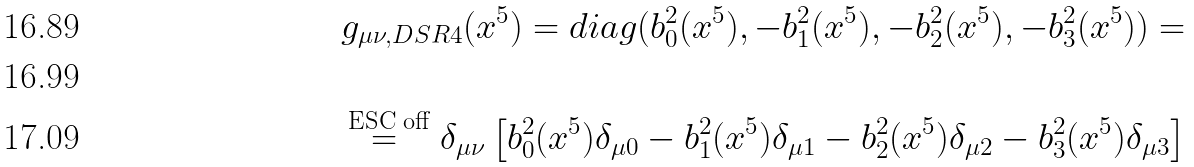Convert formula to latex. <formula><loc_0><loc_0><loc_500><loc_500>g _ { \mu \nu , D S R 4 } ( x ^ { 5 } ) = d i a g ( b _ { 0 } ^ { 2 } ( x ^ { 5 } ) , - b _ { 1 } ^ { 2 } ( x ^ { 5 } ) , - b _ { 2 } ^ { 2 } ( x ^ { 5 } ) , - b _ { 3 } ^ { 2 } ( x ^ { 5 } ) ) = \\ \\ \stackrel { \text { ESC off} } { = } \delta _ { \mu \nu } \left [ b _ { 0 } ^ { 2 } ( x ^ { 5 } ) \delta _ { \mu 0 } - b _ { 1 } ^ { 2 } ( x ^ { 5 } ) \delta _ { \mu 1 } - b _ { 2 } ^ { 2 } ( x ^ { 5 } ) \delta _ { \mu 2 } - b _ { 3 } ^ { 2 } ( x ^ { 5 } ) \delta _ { \mu 3 } \right ]</formula> 